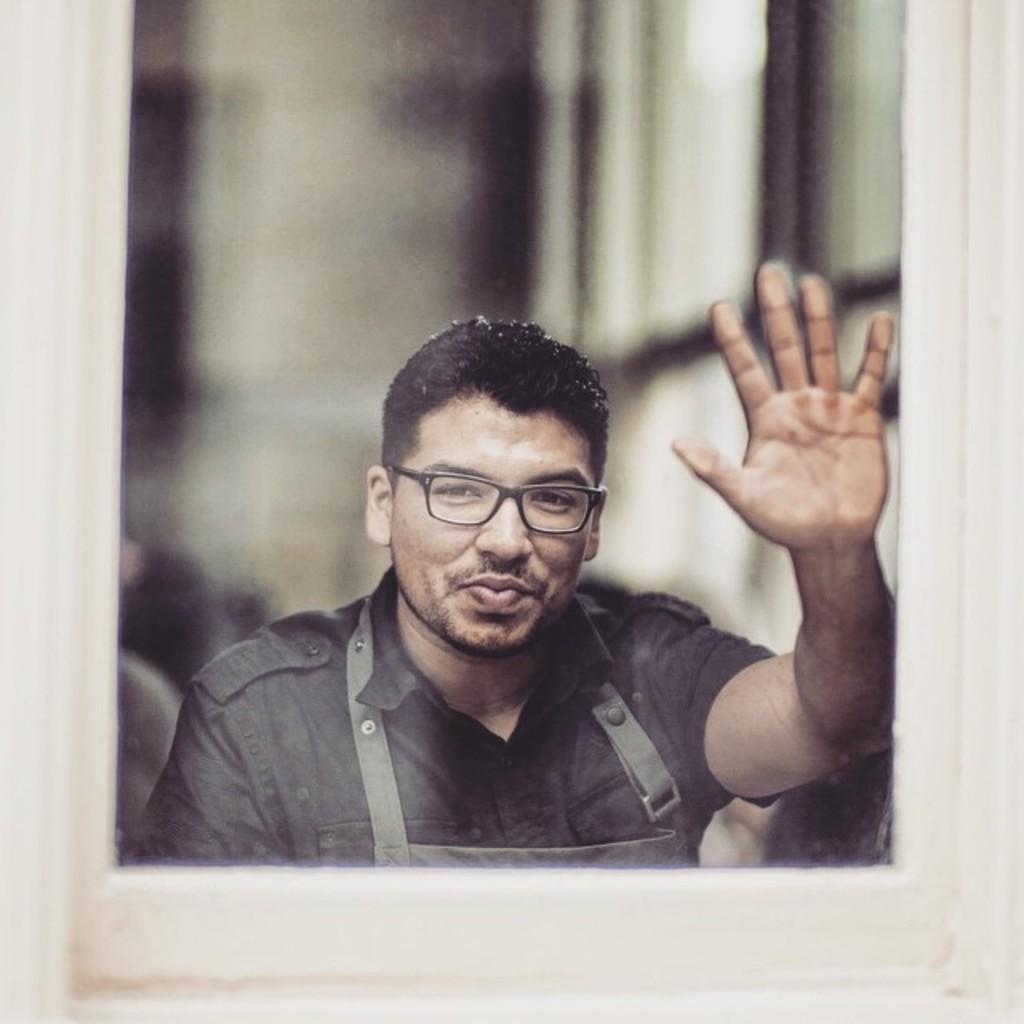How would you summarize this image in a sentence or two? This image consists of a photo frame. In which there is a man wearing black shirt. The background is blurred. The frame is in white color. 